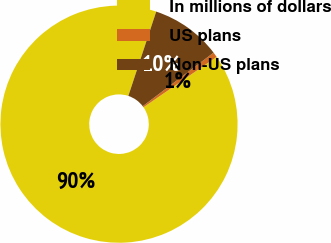<chart> <loc_0><loc_0><loc_500><loc_500><pie_chart><fcel>In millions of dollars<fcel>US plans<fcel>Non-US plans<nl><fcel>89.68%<fcel>0.71%<fcel>9.61%<nl></chart> 